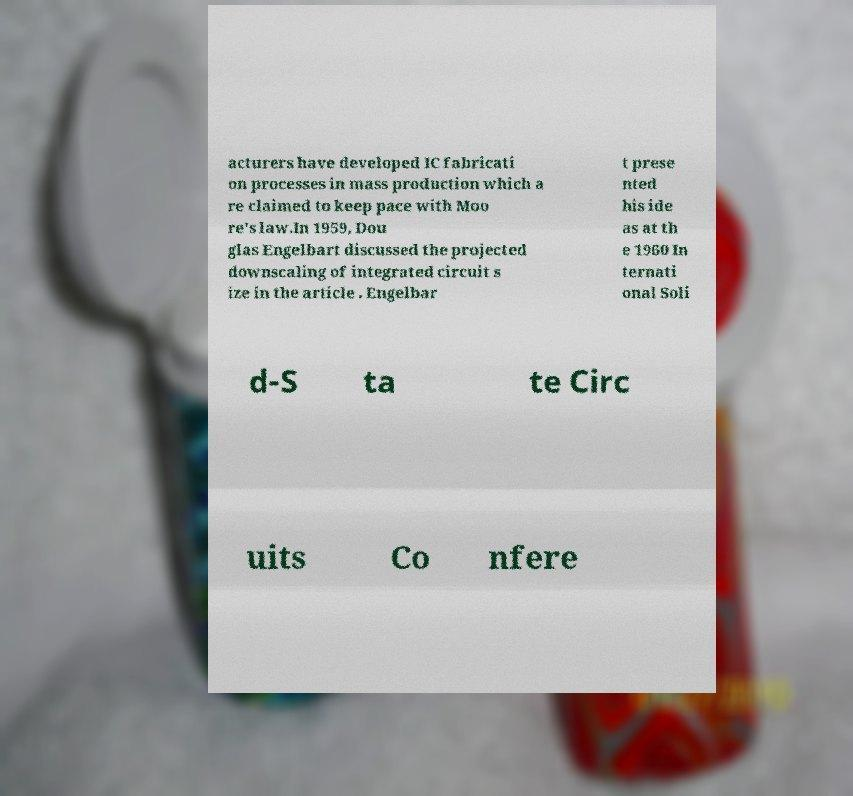There's text embedded in this image that I need extracted. Can you transcribe it verbatim? acturers have developed IC fabricati on processes in mass production which a re claimed to keep pace with Moo re's law.In 1959, Dou glas Engelbart discussed the projected downscaling of integrated circuit s ize in the article . Engelbar t prese nted his ide as at th e 1960 In ternati onal Soli d-S ta te Circ uits Co nfere 